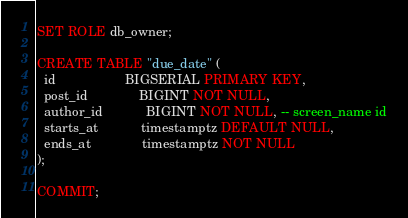Convert code to text. <code><loc_0><loc_0><loc_500><loc_500><_SQL_>
SET ROLE db_owner;

CREATE TABLE "due_date" (
  id                   BIGSERIAL PRIMARY KEY,
  post_id              BIGINT NOT NULL,
  author_id            BIGINT NOT NULL, -- screen_name id
  starts_at            timestamptz DEFAULT NULL,
  ends_at              timestamptz NOT NULL
);

COMMIT;
</code> 